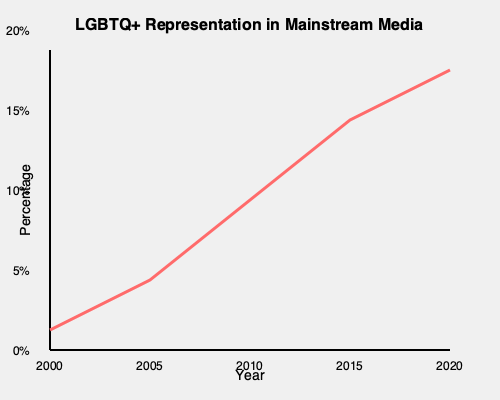Based on the graph, what is the approximate percentage increase in LGBTQ+ representation in mainstream media from 2000 to 2020? How might this trend impact your artistic expression of diverse LGBTQ+ experiences? To answer this question, we need to follow these steps:

1. Identify the starting point (2000) and ending point (2020) on the graph.
2. Estimate the percentage values for these two points:
   - 2000: Approximately 1%
   - 2020: Approximately 14%
3. Calculate the percentage increase:
   $\text{Increase} = \text{End Value} - \text{Start Value}$
   $\text{Increase} = 14\% - 1\% = 13\%$

4. Consider the impact on artistic expression:
   - This significant increase in representation provides more visibility for LGBTQ+ stories and experiences.
   - It may allow for a wider range of LGBTQ+ narratives to be explored in art.
   - The trend could inspire artists to delve deeper into nuanced or underrepresented aspects of LGBTQ+ experiences.
   - Increased representation might also lead to more diverse audience engagement with LGBTQ+ themed artwork.
   - Artists might feel encouraged to push boundaries further, knowing there's a growing acceptance and interest in LGBTQ+ content.

The trend shows a substantial increase in representation, which could provide more opportunities and inspiration for artists to express diverse LGBTQ+ experiences through their work.
Answer: 13% increase; potentially inspiring more diverse and nuanced LGBTQ+ artistic expressions. 